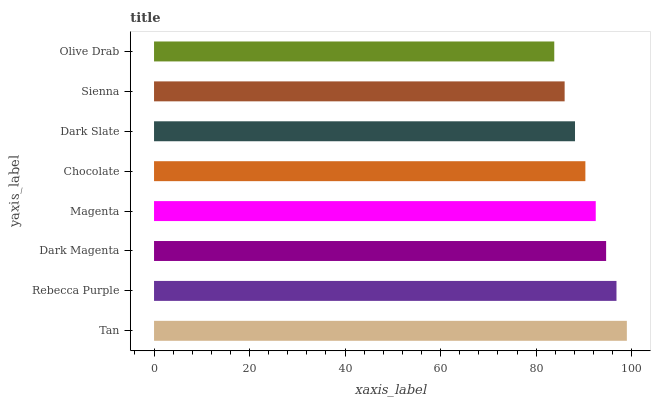Is Olive Drab the minimum?
Answer yes or no. Yes. Is Tan the maximum?
Answer yes or no. Yes. Is Rebecca Purple the minimum?
Answer yes or no. No. Is Rebecca Purple the maximum?
Answer yes or no. No. Is Tan greater than Rebecca Purple?
Answer yes or no. Yes. Is Rebecca Purple less than Tan?
Answer yes or no. Yes. Is Rebecca Purple greater than Tan?
Answer yes or no. No. Is Tan less than Rebecca Purple?
Answer yes or no. No. Is Magenta the high median?
Answer yes or no. Yes. Is Chocolate the low median?
Answer yes or no. Yes. Is Olive Drab the high median?
Answer yes or no. No. Is Dark Magenta the low median?
Answer yes or no. No. 